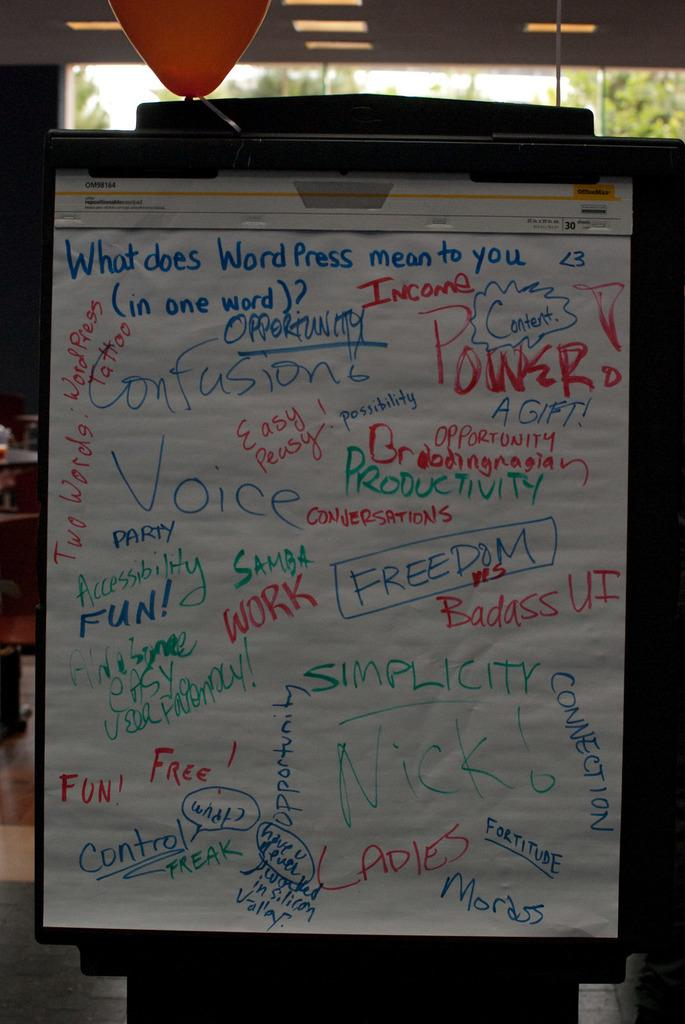Provide a one-sentence caption for the provided image. A large sheet of paper detailing the meaning of Word Press is displayed. 